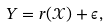<formula> <loc_0><loc_0><loc_500><loc_500>Y = r ( \mathcal { X } ) + \epsilon ,</formula> 